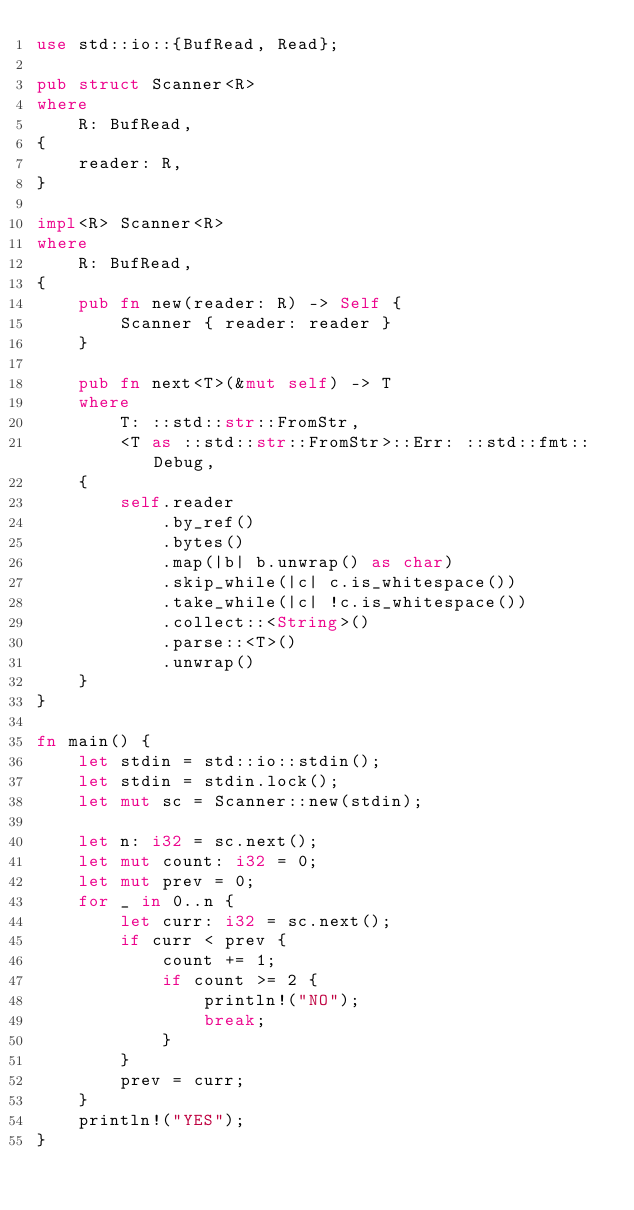Convert code to text. <code><loc_0><loc_0><loc_500><loc_500><_Rust_>use std::io::{BufRead, Read};

pub struct Scanner<R>
where
    R: BufRead,
{
    reader: R,
}

impl<R> Scanner<R>
where
    R: BufRead,
{
    pub fn new(reader: R) -> Self {
        Scanner { reader: reader }
    }

    pub fn next<T>(&mut self) -> T
    where
        T: ::std::str::FromStr,
        <T as ::std::str::FromStr>::Err: ::std::fmt::Debug,
    {
        self.reader
            .by_ref()
            .bytes()
            .map(|b| b.unwrap() as char)
            .skip_while(|c| c.is_whitespace())
            .take_while(|c| !c.is_whitespace())
            .collect::<String>()
            .parse::<T>()
            .unwrap()
    }
}

fn main() {
    let stdin = std::io::stdin();
    let stdin = stdin.lock();
    let mut sc = Scanner::new(stdin);

    let n: i32 = sc.next();
    let mut count: i32 = 0;
    let mut prev = 0;
    for _ in 0..n {
        let curr: i32 = sc.next();
        if curr < prev {
            count += 1;
            if count >= 2 {
                println!("NO");
                break;
            }
        }
        prev = curr;
    }
    println!("YES");
}
</code> 